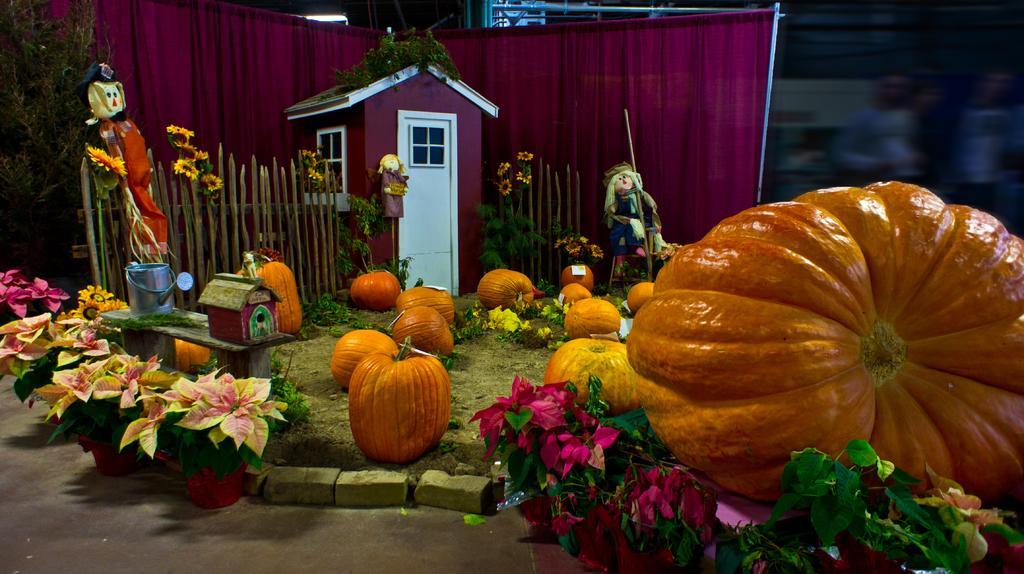Please provide a concise description of this image. In this image I can see toys, pumpkins, flowers and other objects. 